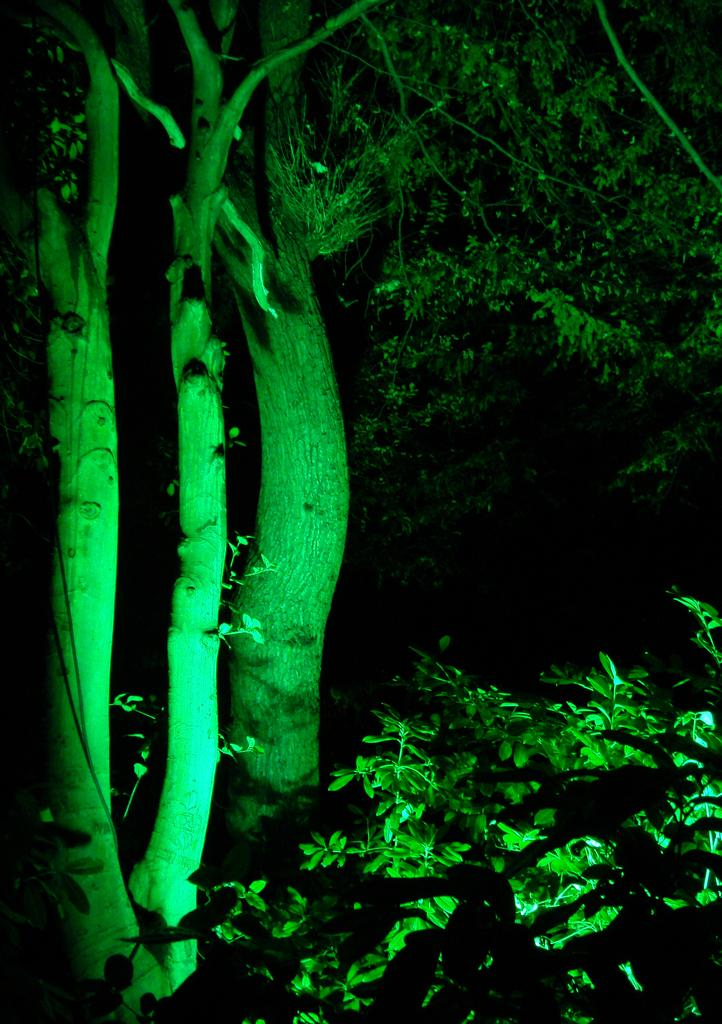What types of vegetation are in the foreground of the image? There are trees and plants in the foreground of the image. Can you describe the location of the vegetation in the image? The vegetation is in the foreground, which means it is closest to the viewer. Where is the crate located in the image? There is no crate present in the image. What is the girl doing in the image? There is no girl present in the image. 